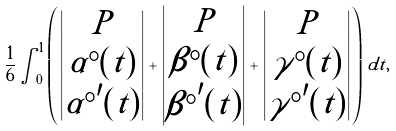<formula> <loc_0><loc_0><loc_500><loc_500>\frac { 1 } { 6 } \int _ { 0 } ^ { 1 } \left ( \begin{vmatrix} P \\ \alpha ^ { \circ } ( t ) \\ { \alpha ^ { \circ } } ^ { \prime } ( t ) \end{vmatrix} + \begin{vmatrix} P \\ \beta ^ { \circ } ( t ) \\ { \beta ^ { \circ } } ^ { \prime } ( t ) \end{vmatrix} + \begin{vmatrix} P \\ \gamma ^ { \circ } ( t ) \\ { \gamma ^ { \circ } } ^ { \prime } ( t ) \end{vmatrix} \right ) \, d t ,</formula> 